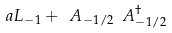<formula> <loc_0><loc_0><loc_500><loc_500>a L _ { - 1 } + \ A _ { - 1 / 2 } \ A ^ { \dagger } _ { - 1 / 2 }</formula> 